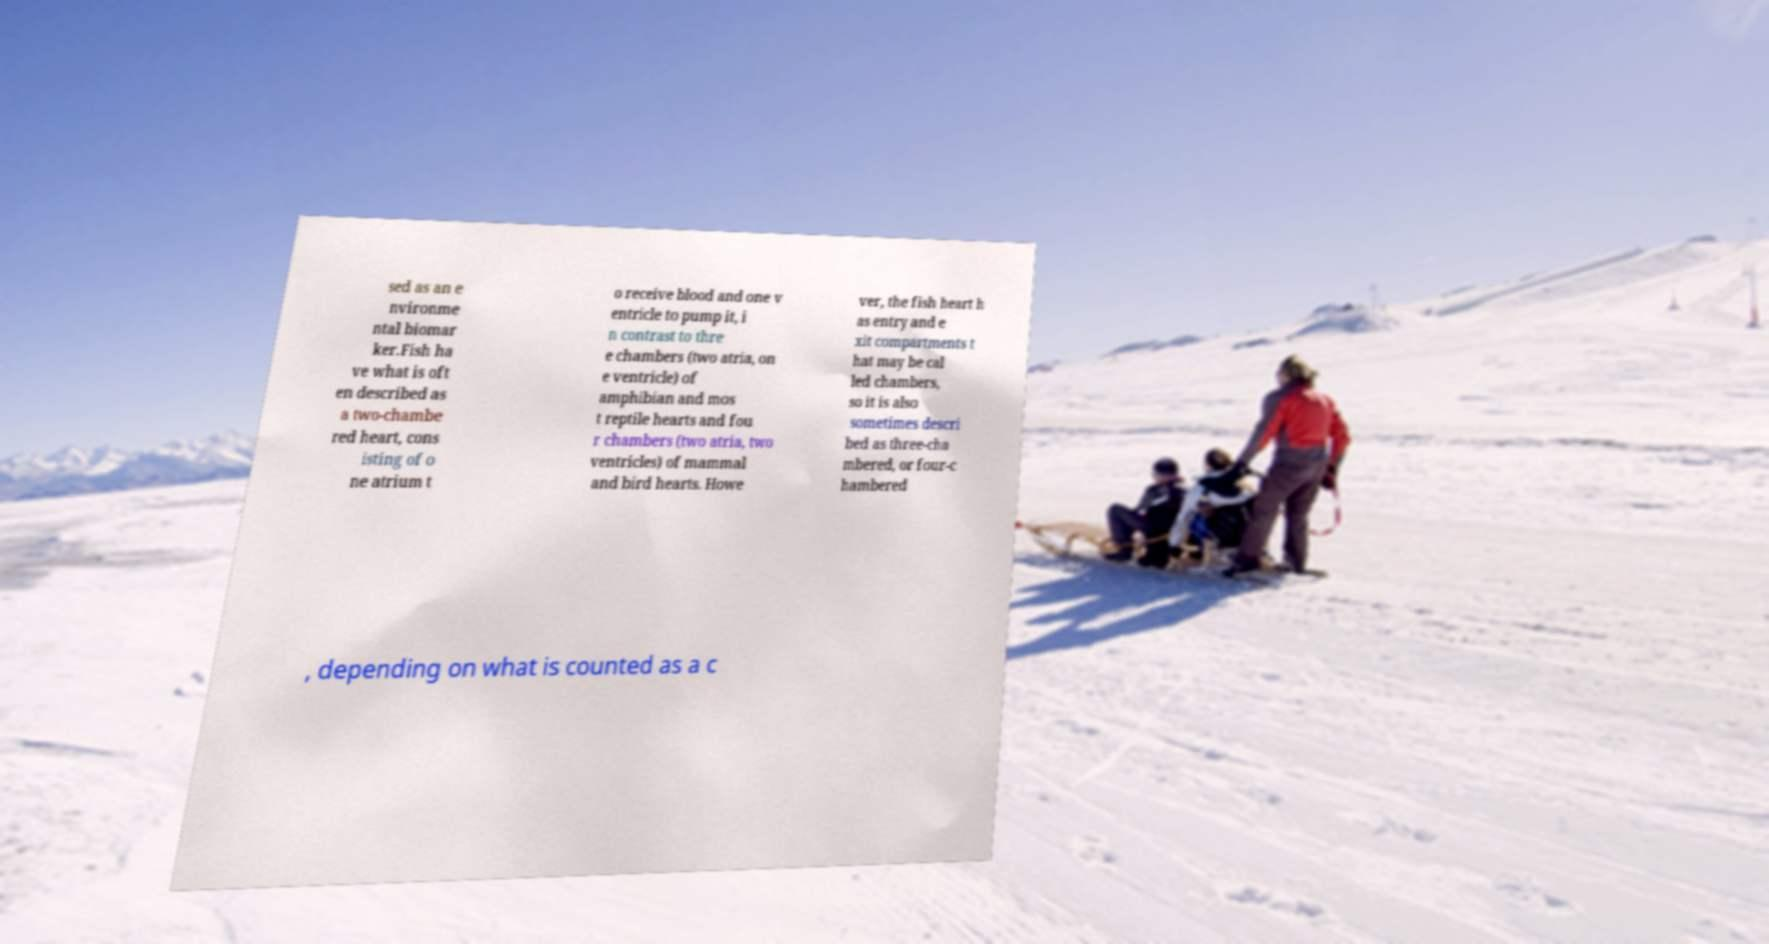Could you assist in decoding the text presented in this image and type it out clearly? sed as an e nvironme ntal biomar ker.Fish ha ve what is oft en described as a two-chambe red heart, cons isting of o ne atrium t o receive blood and one v entricle to pump it, i n contrast to thre e chambers (two atria, on e ventricle) of amphibian and mos t reptile hearts and fou r chambers (two atria, two ventricles) of mammal and bird hearts. Howe ver, the fish heart h as entry and e xit compartments t hat may be cal led chambers, so it is also sometimes descri bed as three-cha mbered, or four-c hambered , depending on what is counted as a c 